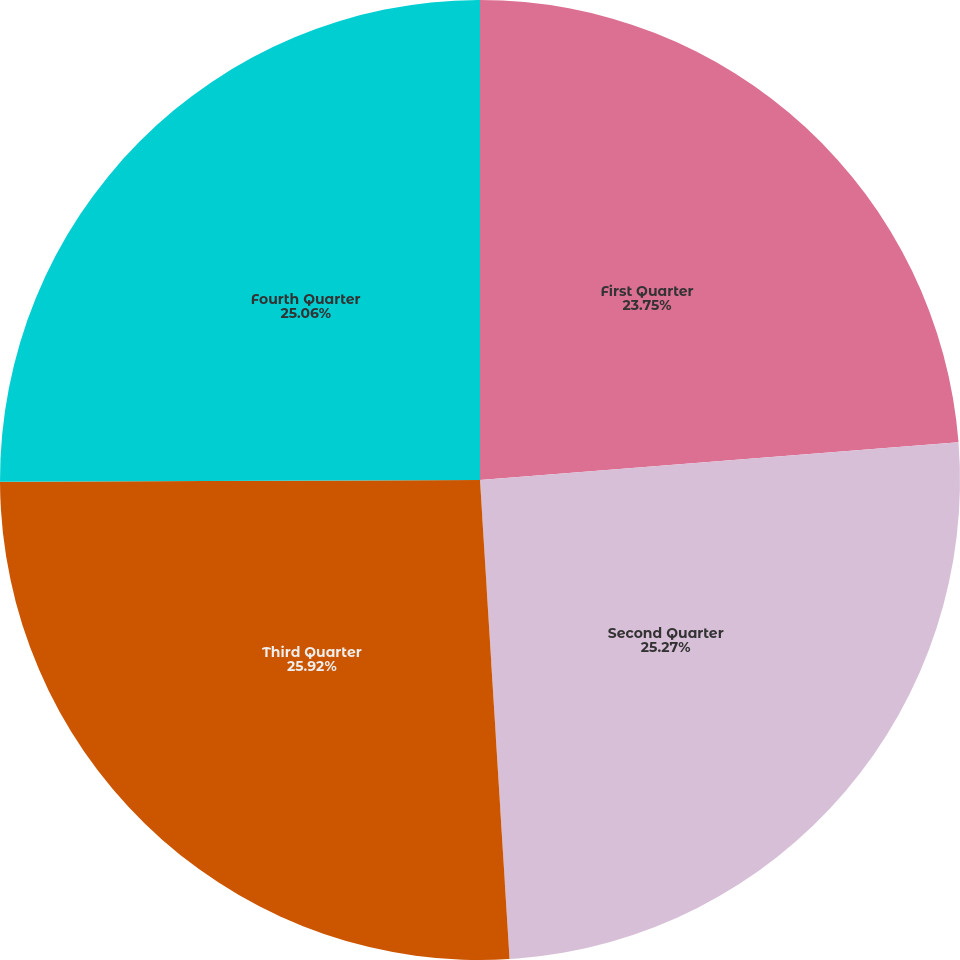Convert chart to OTSL. <chart><loc_0><loc_0><loc_500><loc_500><pie_chart><fcel>First Quarter<fcel>Second Quarter<fcel>Third Quarter<fcel>Fourth Quarter<nl><fcel>23.75%<fcel>25.27%<fcel>25.92%<fcel>25.06%<nl></chart> 